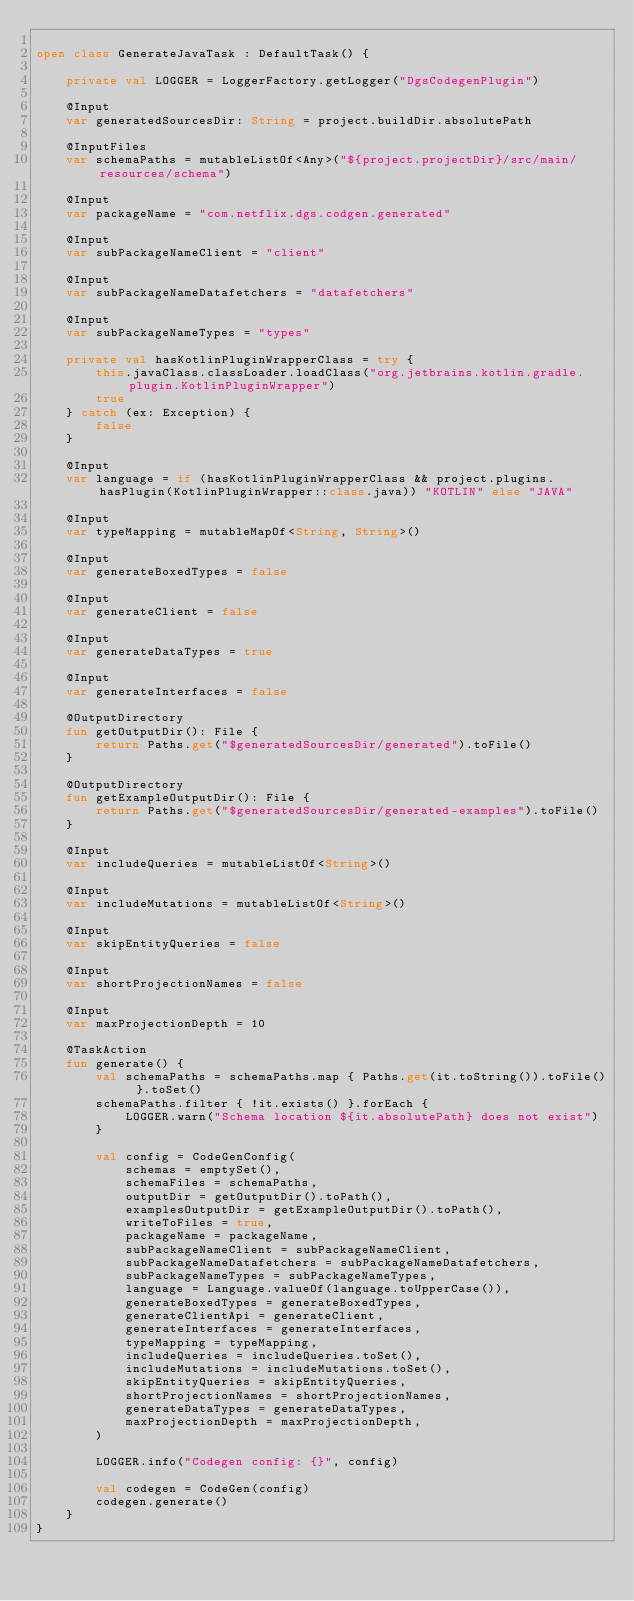Convert code to text. <code><loc_0><loc_0><loc_500><loc_500><_Kotlin_>
open class GenerateJavaTask : DefaultTask() {

    private val LOGGER = LoggerFactory.getLogger("DgsCodegenPlugin")

    @Input
    var generatedSourcesDir: String = project.buildDir.absolutePath

    @InputFiles
    var schemaPaths = mutableListOf<Any>("${project.projectDir}/src/main/resources/schema")

    @Input
    var packageName = "com.netflix.dgs.codgen.generated"

    @Input
    var subPackageNameClient = "client"

    @Input
    var subPackageNameDatafetchers = "datafetchers"

    @Input
    var subPackageNameTypes = "types"

    private val hasKotlinPluginWrapperClass = try {
        this.javaClass.classLoader.loadClass("org.jetbrains.kotlin.gradle.plugin.KotlinPluginWrapper")
        true
    } catch (ex: Exception) {
        false
    }

    @Input
    var language = if (hasKotlinPluginWrapperClass && project.plugins.hasPlugin(KotlinPluginWrapper::class.java)) "KOTLIN" else "JAVA"

    @Input
    var typeMapping = mutableMapOf<String, String>()

    @Input
    var generateBoxedTypes = false

    @Input
    var generateClient = false

    @Input
    var generateDataTypes = true

    @Input
    var generateInterfaces = false

    @OutputDirectory
    fun getOutputDir(): File {
        return Paths.get("$generatedSourcesDir/generated").toFile()
    }

    @OutputDirectory
    fun getExampleOutputDir(): File {
        return Paths.get("$generatedSourcesDir/generated-examples").toFile()
    }

    @Input
    var includeQueries = mutableListOf<String>()

    @Input
    var includeMutations = mutableListOf<String>()

    @Input
    var skipEntityQueries = false

    @Input
    var shortProjectionNames = false

    @Input
    var maxProjectionDepth = 10

    @TaskAction
    fun generate() {
        val schemaPaths = schemaPaths.map { Paths.get(it.toString()).toFile() }.toSet()
        schemaPaths.filter { !it.exists() }.forEach {
            LOGGER.warn("Schema location ${it.absolutePath} does not exist")
        }

        val config = CodeGenConfig(
            schemas = emptySet(),
            schemaFiles = schemaPaths,
            outputDir = getOutputDir().toPath(),
            examplesOutputDir = getExampleOutputDir().toPath(),
            writeToFiles = true,
            packageName = packageName,
            subPackageNameClient = subPackageNameClient,
            subPackageNameDatafetchers = subPackageNameDatafetchers,
            subPackageNameTypes = subPackageNameTypes,
            language = Language.valueOf(language.toUpperCase()),
            generateBoxedTypes = generateBoxedTypes,
            generateClientApi = generateClient,
            generateInterfaces = generateInterfaces,
            typeMapping = typeMapping,
            includeQueries = includeQueries.toSet(),
            includeMutations = includeMutations.toSet(),
            skipEntityQueries = skipEntityQueries,
            shortProjectionNames = shortProjectionNames,
            generateDataTypes = generateDataTypes,
            maxProjectionDepth = maxProjectionDepth,
        )

        LOGGER.info("Codegen config: {}", config)

        val codegen = CodeGen(config)
        codegen.generate()
    }
}
</code> 